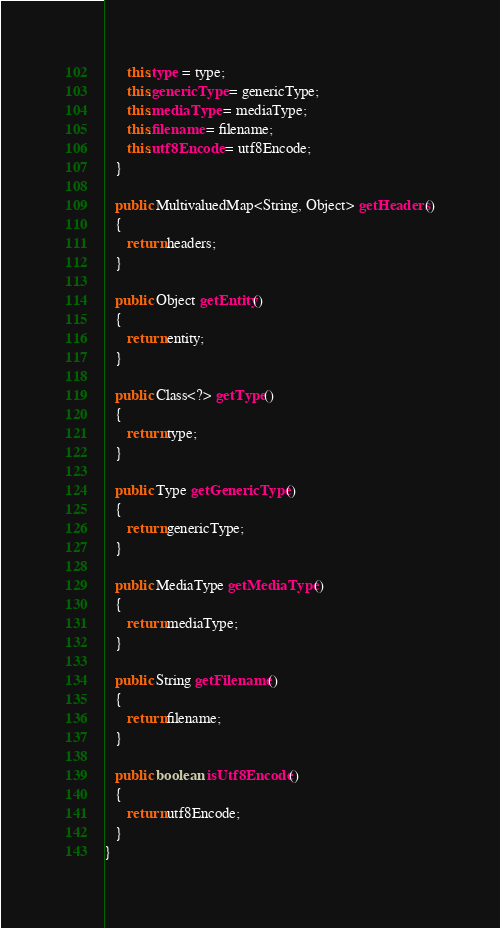<code> <loc_0><loc_0><loc_500><loc_500><_Java_>      this.type = type;
      this.genericType = genericType;
      this.mediaType = mediaType;
      this.filename = filename;
      this.utf8Encode = utf8Encode;
   }

   public MultivaluedMap<String, Object> getHeaders()
   {
      return headers;
   }

   public Object getEntity()
   {
      return entity;
   }

   public Class<?> getType()
   {
      return type;
   }

   public Type getGenericType()
   {
      return genericType;
   }

   public MediaType getMediaType()
   {
      return mediaType;
   }

   public String getFilename()
   {
      return filename;
   }

   public boolean isUtf8Encode()
   {
      return utf8Encode;
   }
}
</code> 